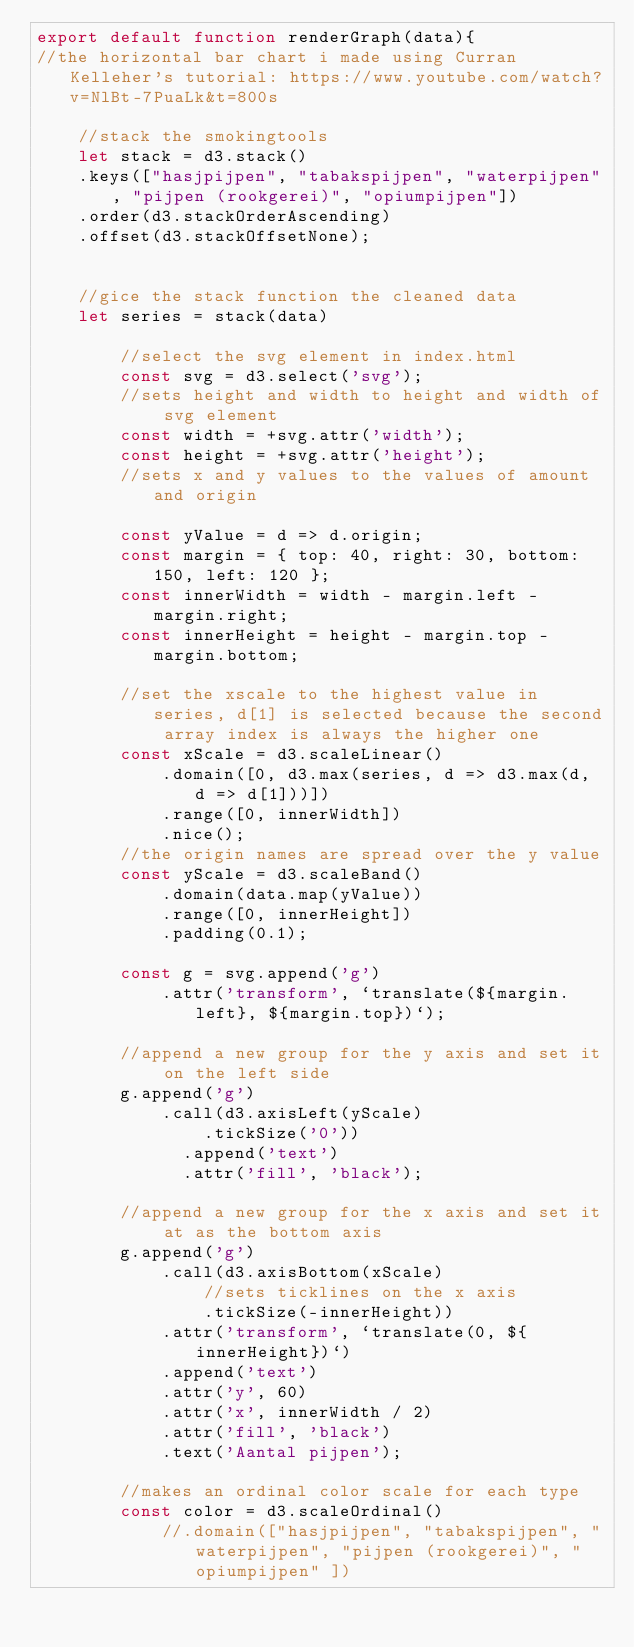<code> <loc_0><loc_0><loc_500><loc_500><_JavaScript_>export default function renderGraph(data){
//the horizontal bar chart i made using Curran Kelleher's tutorial: https://www.youtube.com/watch?v=NlBt-7PuaLk&t=800s

    //stack the smokingtools
    let stack = d3.stack()
    .keys(["hasjpijpen", "tabakspijpen", "waterpijpen", "pijpen (rookgerei)", "opiumpijpen"])
    .order(d3.stackOrderAscending)
    .offset(d3.stackOffsetNone);

    
    //gice the stack function the cleaned data
    let series = stack(data)

        //select the svg element in index.html
        const svg = d3.select('svg');
        //sets height and width to height and width of svg element
        const width = +svg.attr('width');
        const height = +svg.attr('height');
        //sets x and y values to the values of amount and origin

        const yValue = d => d.origin;
        const margin = { top: 40, right: 30, bottom: 150, left: 120 };
        const innerWidth = width - margin.left - margin.right;
        const innerHeight = height - margin.top - margin.bottom;
      
        //set the xscale to the highest value in series, d[1] is selected because the second array index is always the higher one
        const xScale = d3.scaleLinear()
            .domain([0, d3.max(series, d => d3.max(d, d => d[1]))])
            .range([0, innerWidth])
            .nice();
        //the origin names are spread over the y value
        const yScale = d3.scaleBand()
            .domain(data.map(yValue))
            .range([0, innerHeight])
            .padding(0.1);
      
        const g = svg.append('g')
            .attr('transform', `translate(${margin.left}, ${margin.top})`);
      
        //append a new group for the y axis and set it on the left side
        g.append('g')
            .call(d3.axisLeft(yScale)
                .tickSize('0'))
              .append('text')
              .attr('fill', 'black');
      
        //append a new group for the x axis and set it at as the bottom axis
        g.append('g')
            .call(d3.axisBottom(xScale)
                //sets ticklines on the x axis
                .tickSize(-innerHeight))
            .attr('transform', `translate(0, ${innerHeight})`)
            .append('text')
            .attr('y', 60)
            .attr('x', innerWidth / 2)
            .attr('fill', 'black')
            .text('Aantal pijpen');
    
        //makes an ordinal color scale for each type
        const color = d3.scaleOrdinal()
            //.domain(["hasjpijpen", "tabakspijpen", "waterpijpen", "pijpen (rookgerei)", "opiumpijpen" ])</code> 